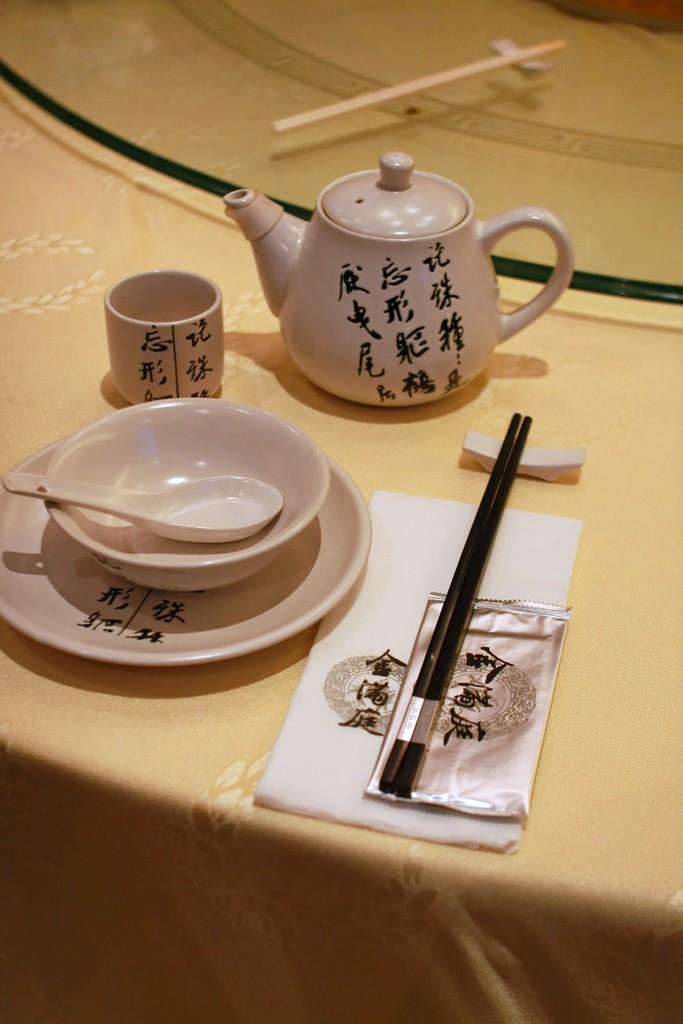Describe this image in one or two sentences. On a table there is a cup, bowl, spoon, plate, chopsticks and a teapot. 